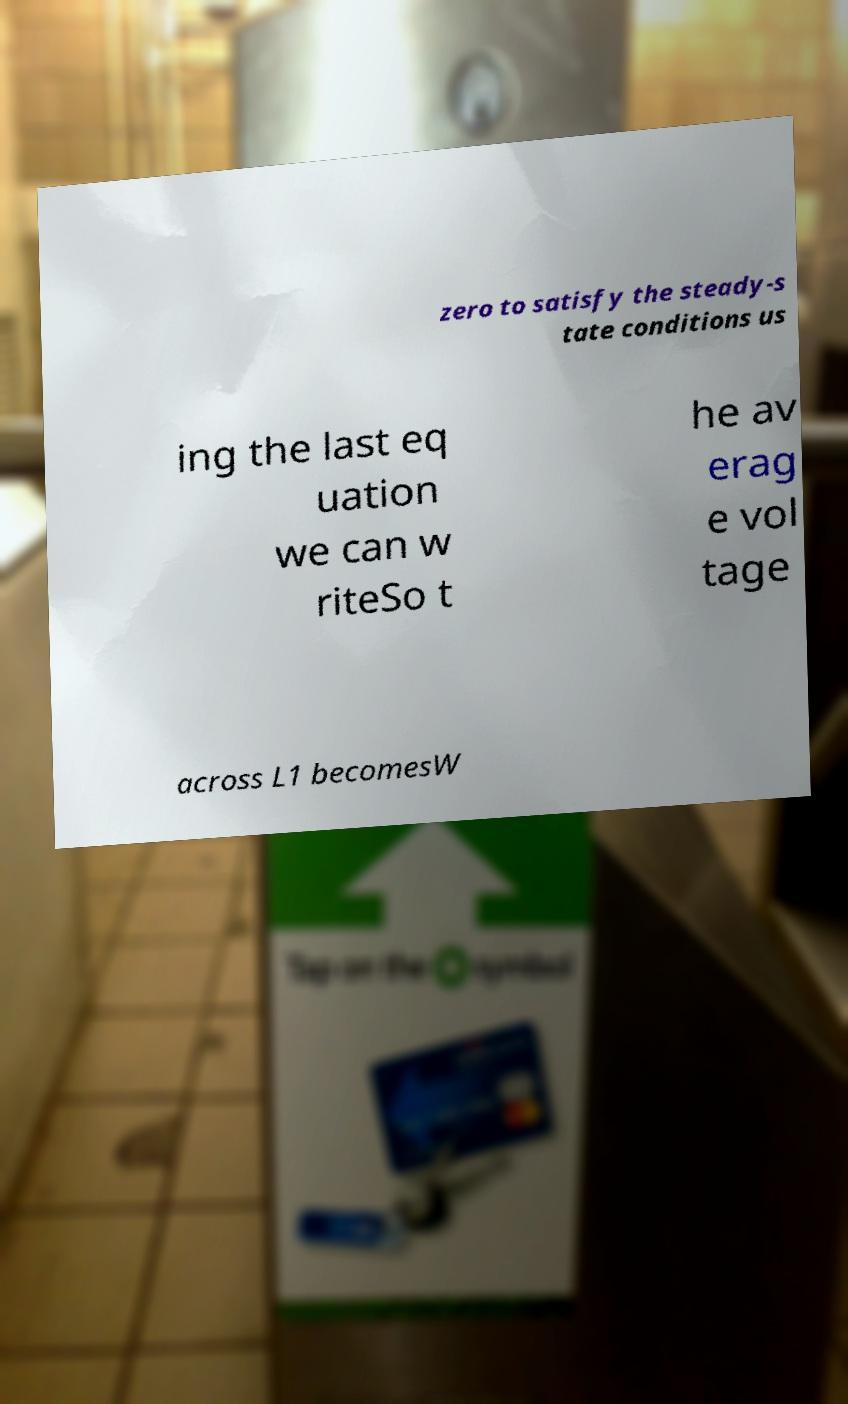There's text embedded in this image that I need extracted. Can you transcribe it verbatim? zero to satisfy the steady-s tate conditions us ing the last eq uation we can w riteSo t he av erag e vol tage across L1 becomesW 